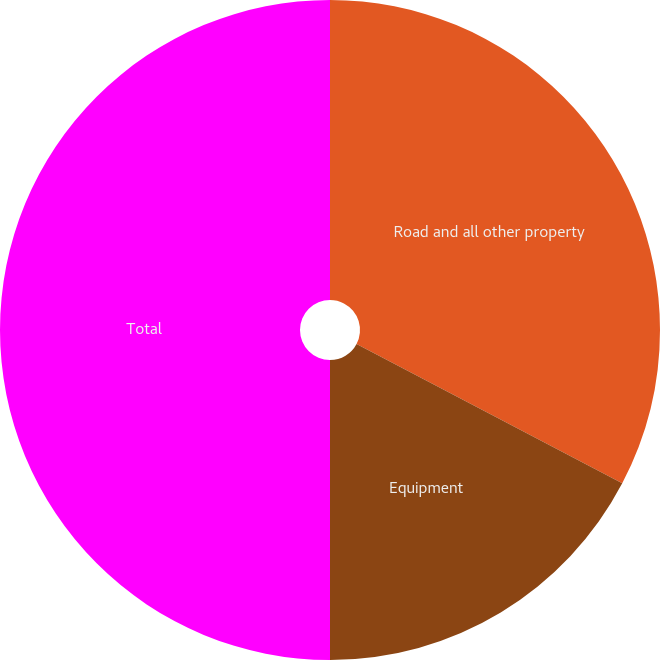<chart> <loc_0><loc_0><loc_500><loc_500><pie_chart><fcel>Road and all other property<fcel>Equipment<fcel>Total<nl><fcel>32.69%<fcel>17.31%<fcel>50.0%<nl></chart> 